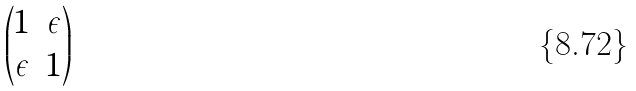<formula> <loc_0><loc_0><loc_500><loc_500>\begin{pmatrix} 1 & \epsilon \\ \epsilon & 1 \end{pmatrix}</formula> 